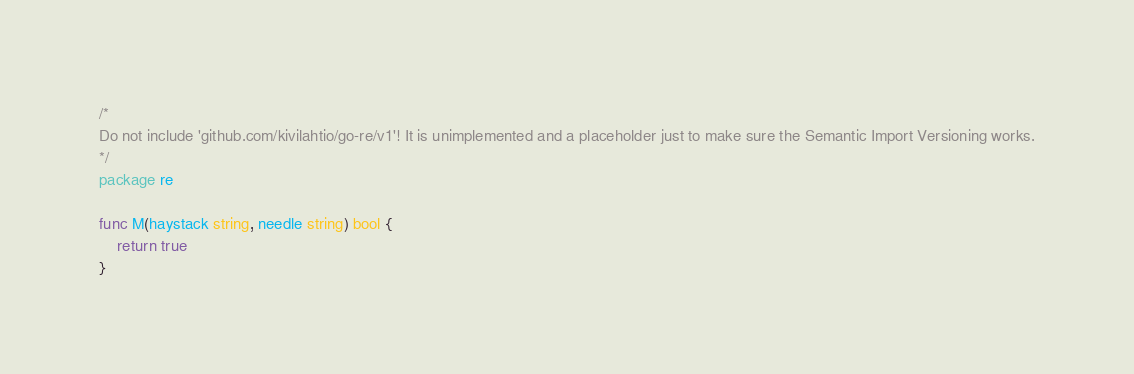<code> <loc_0><loc_0><loc_500><loc_500><_Go_>/*
Do not include 'github.com/kivilahtio/go-re/v1'! It is unimplemented and a placeholder just to make sure the Semantic Import Versioning works.
*/
package re

func M(haystack string, needle string) bool {
	return true
}
</code> 